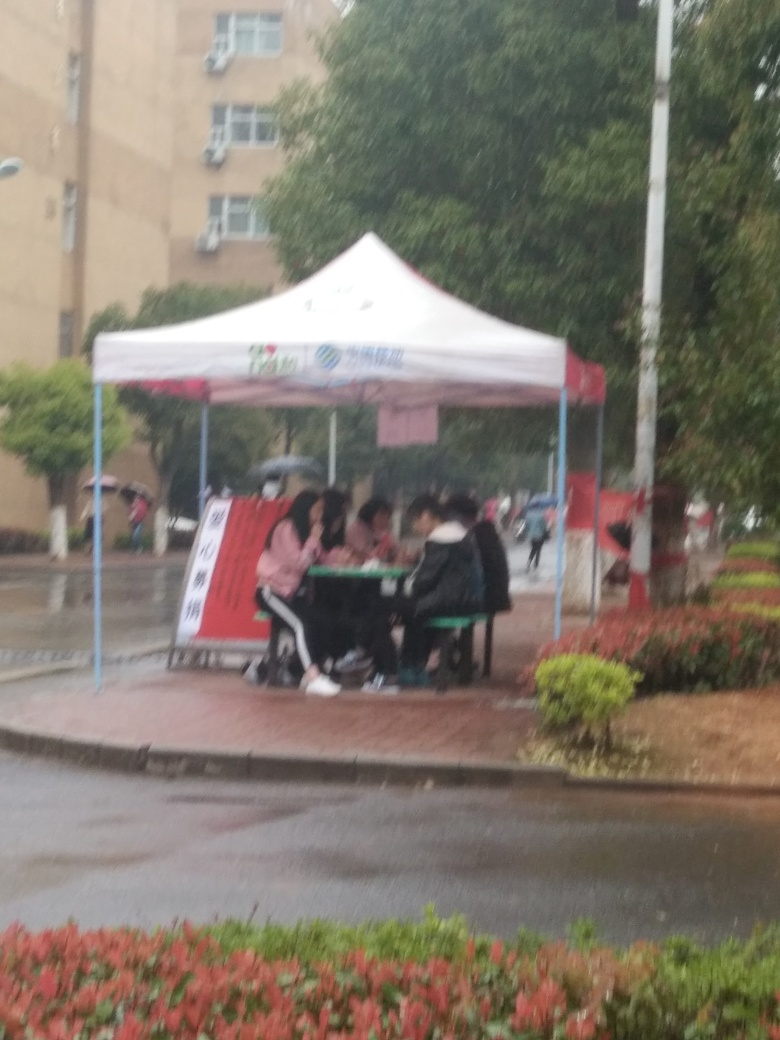Why are people gathered under the tent? The people are likely gathered under the tent to find shelter from the rain and possibly to engage in an outdoor event or activity that has been planned despite the weather, such as community gathering or info desk. 